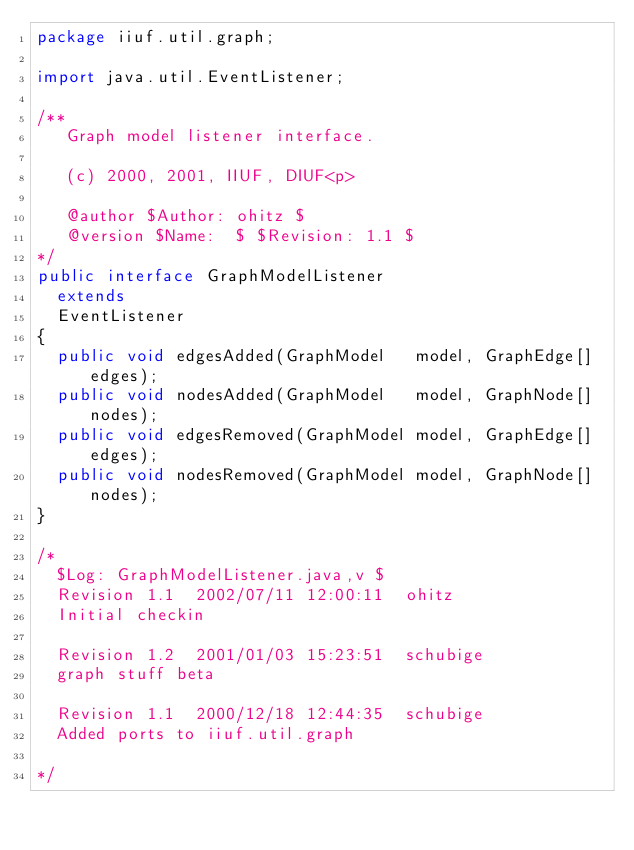Convert code to text. <code><loc_0><loc_0><loc_500><loc_500><_Java_>package iiuf.util.graph;

import java.util.EventListener;

/**
   Graph model listener interface.

   (c) 2000, 2001, IIUF, DIUF<p>

   @author $Author: ohitz $
   @version $Name:  $ $Revision: 1.1 $
*/
public interface GraphModelListener 
  extends
  EventListener 
{
  public void edgesAdded(GraphModel   model, GraphEdge[] edges);
  public void nodesAdded(GraphModel   model, GraphNode[] nodes);
  public void edgesRemoved(GraphModel model, GraphEdge[] edges);
  public void nodesRemoved(GraphModel model, GraphNode[] nodes); 
}

/*
  $Log: GraphModelListener.java,v $
  Revision 1.1  2002/07/11 12:00:11  ohitz
  Initial checkin

  Revision 1.2  2001/01/03 15:23:51  schubige
  graph stuff beta

  Revision 1.1  2000/12/18 12:44:35  schubige
  Added ports to iiuf.util.graph
  
*/
</code> 